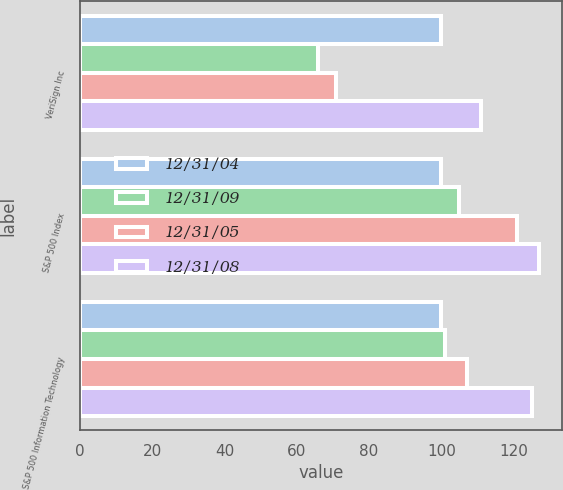<chart> <loc_0><loc_0><loc_500><loc_500><stacked_bar_chart><ecel><fcel>VeriSign Inc<fcel>S&P 500 Index<fcel>S&P 500 Information Technology<nl><fcel>12/31/04<fcel>100<fcel>100<fcel>100<nl><fcel>12/31/09<fcel>66<fcel>105<fcel>101<nl><fcel>12/31/05<fcel>71<fcel>121<fcel>107<nl><fcel>12/31/08<fcel>111<fcel>127<fcel>125<nl></chart> 